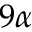Convert formula to latex. <formula><loc_0><loc_0><loc_500><loc_500>9 \alpha</formula> 